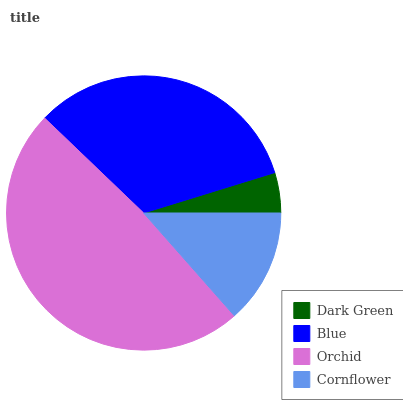Is Dark Green the minimum?
Answer yes or no. Yes. Is Orchid the maximum?
Answer yes or no. Yes. Is Blue the minimum?
Answer yes or no. No. Is Blue the maximum?
Answer yes or no. No. Is Blue greater than Dark Green?
Answer yes or no. Yes. Is Dark Green less than Blue?
Answer yes or no. Yes. Is Dark Green greater than Blue?
Answer yes or no. No. Is Blue less than Dark Green?
Answer yes or no. No. Is Blue the high median?
Answer yes or no. Yes. Is Cornflower the low median?
Answer yes or no. Yes. Is Cornflower the high median?
Answer yes or no. No. Is Orchid the low median?
Answer yes or no. No. 